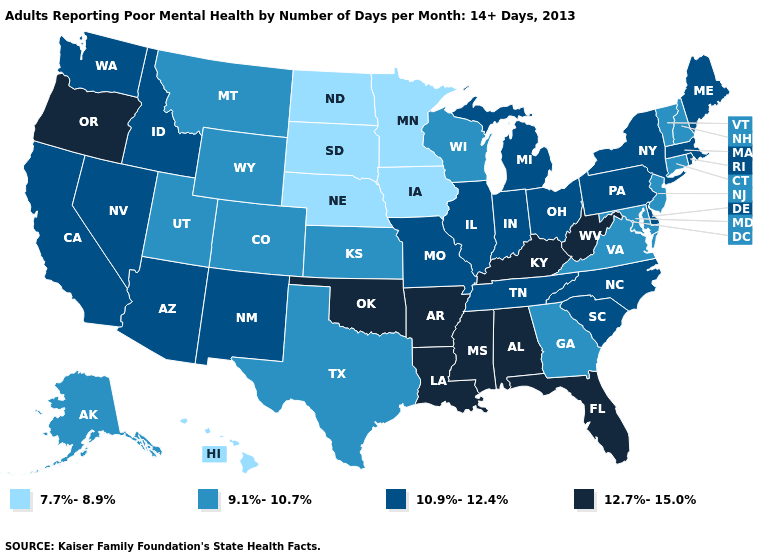What is the value of Wisconsin?
Answer briefly. 9.1%-10.7%. What is the value of Montana?
Answer briefly. 9.1%-10.7%. What is the value of Wisconsin?
Quick response, please. 9.1%-10.7%. Does Washington have a higher value than Arkansas?
Answer briefly. No. Does the map have missing data?
Be succinct. No. Does North Dakota have the lowest value in the MidWest?
Answer briefly. Yes. Which states have the lowest value in the USA?
Quick response, please. Hawaii, Iowa, Minnesota, Nebraska, North Dakota, South Dakota. Is the legend a continuous bar?
Short answer required. No. What is the value of Oklahoma?
Short answer required. 12.7%-15.0%. Name the states that have a value in the range 10.9%-12.4%?
Be succinct. Arizona, California, Delaware, Idaho, Illinois, Indiana, Maine, Massachusetts, Michigan, Missouri, Nevada, New Mexico, New York, North Carolina, Ohio, Pennsylvania, Rhode Island, South Carolina, Tennessee, Washington. Does the first symbol in the legend represent the smallest category?
Concise answer only. Yes. What is the value of New Mexico?
Be succinct. 10.9%-12.4%. Which states have the highest value in the USA?
Be succinct. Alabama, Arkansas, Florida, Kentucky, Louisiana, Mississippi, Oklahoma, Oregon, West Virginia. Does the first symbol in the legend represent the smallest category?
Be succinct. Yes. Does New Mexico have a lower value than Delaware?
Keep it brief. No. 